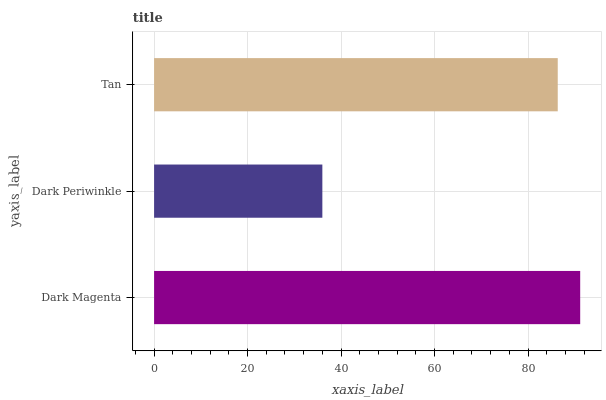Is Dark Periwinkle the minimum?
Answer yes or no. Yes. Is Dark Magenta the maximum?
Answer yes or no. Yes. Is Tan the minimum?
Answer yes or no. No. Is Tan the maximum?
Answer yes or no. No. Is Tan greater than Dark Periwinkle?
Answer yes or no. Yes. Is Dark Periwinkle less than Tan?
Answer yes or no. Yes. Is Dark Periwinkle greater than Tan?
Answer yes or no. No. Is Tan less than Dark Periwinkle?
Answer yes or no. No. Is Tan the high median?
Answer yes or no. Yes. Is Tan the low median?
Answer yes or no. Yes. Is Dark Magenta the high median?
Answer yes or no. No. Is Dark Magenta the low median?
Answer yes or no. No. 